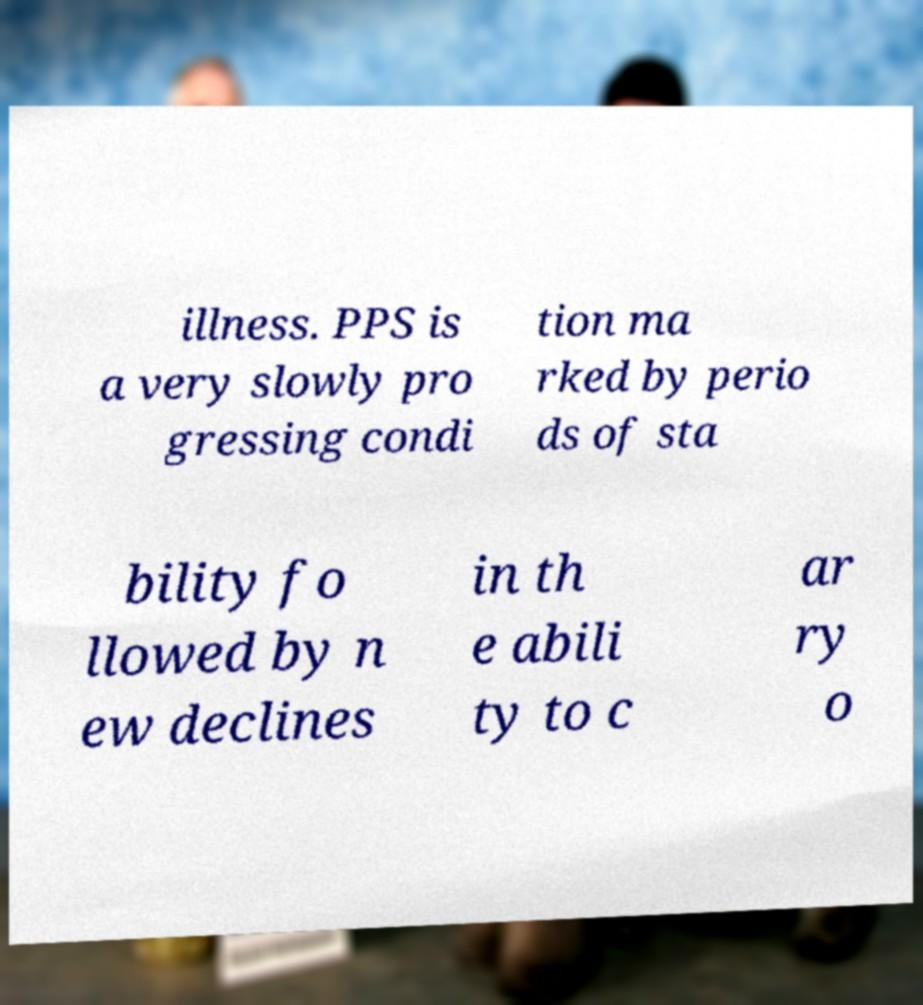Could you assist in decoding the text presented in this image and type it out clearly? illness. PPS is a very slowly pro gressing condi tion ma rked by perio ds of sta bility fo llowed by n ew declines in th e abili ty to c ar ry o 